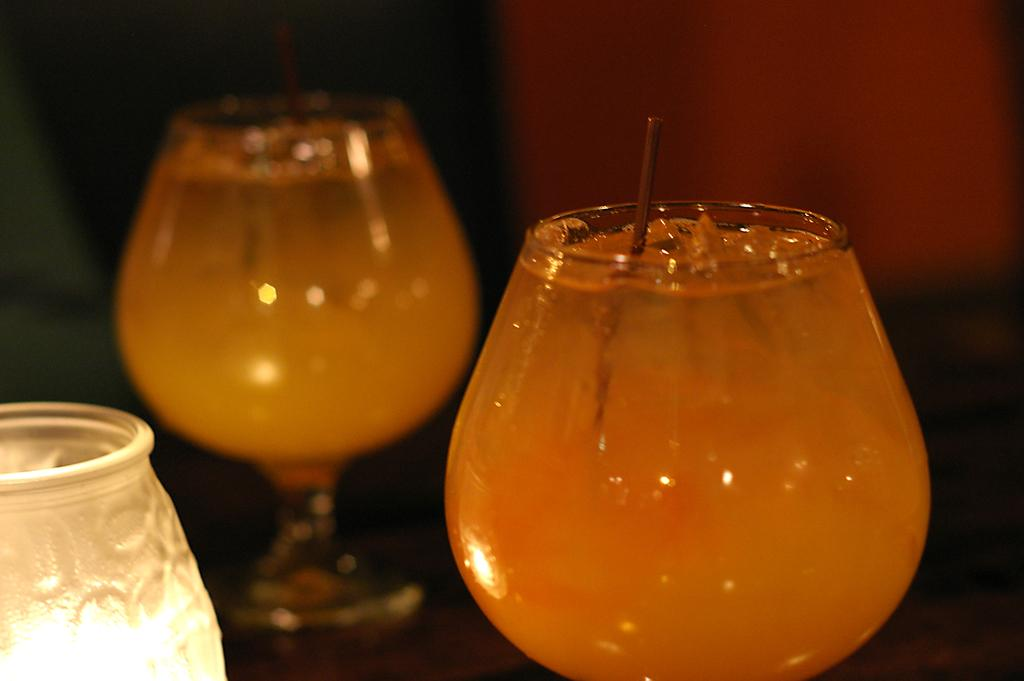What can be seen in the image that contains liquid? There are two glasses of liquid in the image. What object is located on the left side of the image? There is a lamp on the left side of the image. How would you describe the background of the image? The background of the image appears blurry. How many books are visible in the image? There are no books visible in the image. What year is depicted in the image? The image does not depict a specific year. 